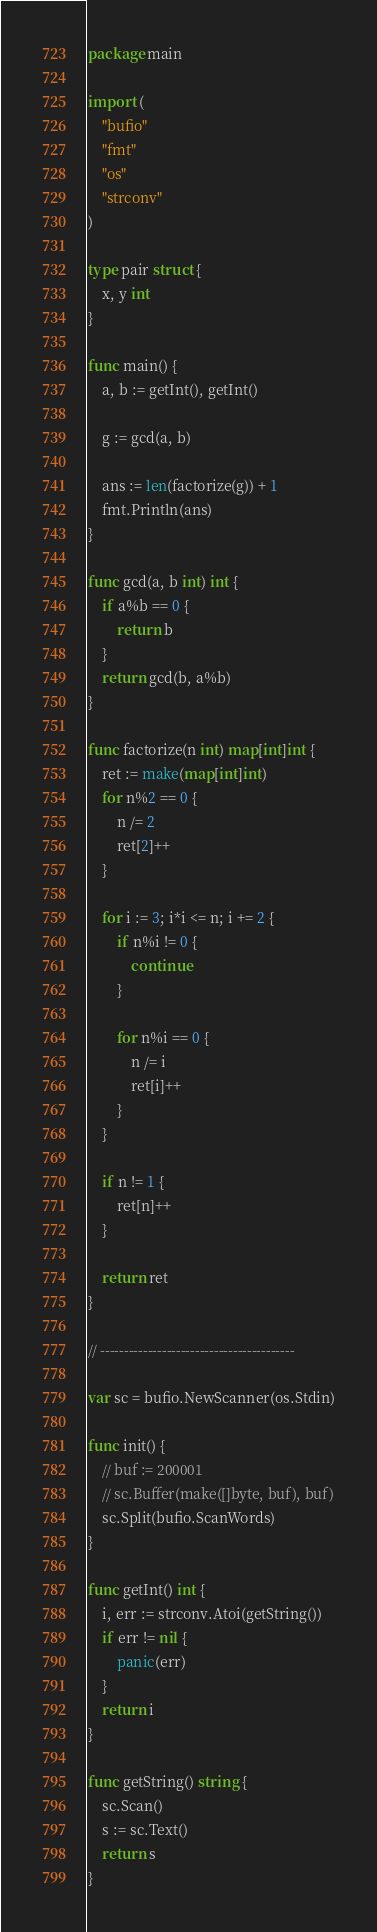Convert code to text. <code><loc_0><loc_0><loc_500><loc_500><_Go_>package main

import (
	"bufio"
	"fmt"
	"os"
	"strconv"
)

type pair struct {
	x, y int
}

func main() {
	a, b := getInt(), getInt()

	g := gcd(a, b)

	ans := len(factorize(g)) + 1
	fmt.Println(ans)
}

func gcd(a, b int) int {
	if a%b == 0 {
		return b
	}
	return gcd(b, a%b)
}

func factorize(n int) map[int]int {
	ret := make(map[int]int)
	for n%2 == 0 {
		n /= 2
		ret[2]++
	}

	for i := 3; i*i <= n; i += 2 {
		if n%i != 0 {
			continue
		}

		for n%i == 0 {
			n /= i
			ret[i]++
		}
	}

	if n != 1 {
		ret[n]++
	}

	return ret
}

// -----------------------------------------

var sc = bufio.NewScanner(os.Stdin)

func init() {
	// buf := 200001
	// sc.Buffer(make([]byte, buf), buf)
	sc.Split(bufio.ScanWords)
}

func getInt() int {
	i, err := strconv.Atoi(getString())
	if err != nil {
		panic(err)
	}
	return i
}

func getString() string {
	sc.Scan()
	s := sc.Text()
	return s
}
</code> 